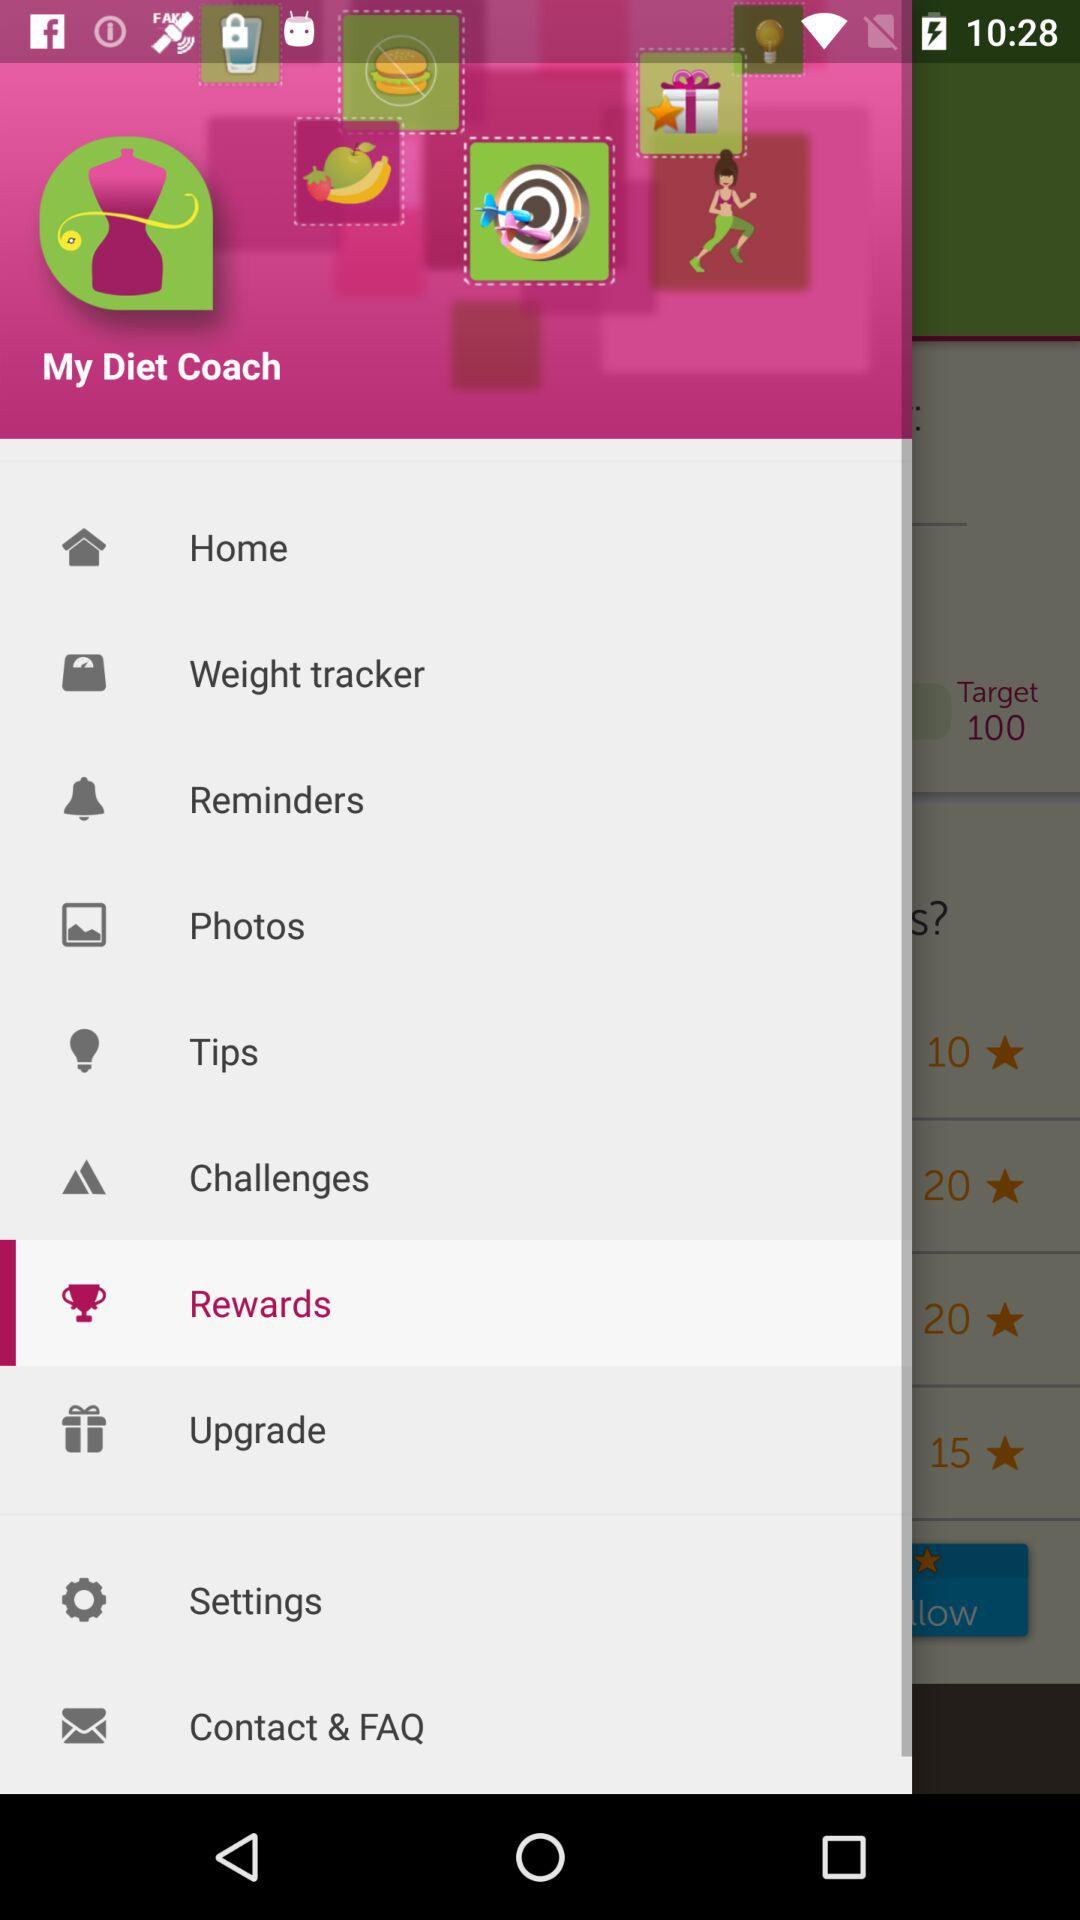Which is the selected item in the menu? The selected item in the menu is "Rewards". 